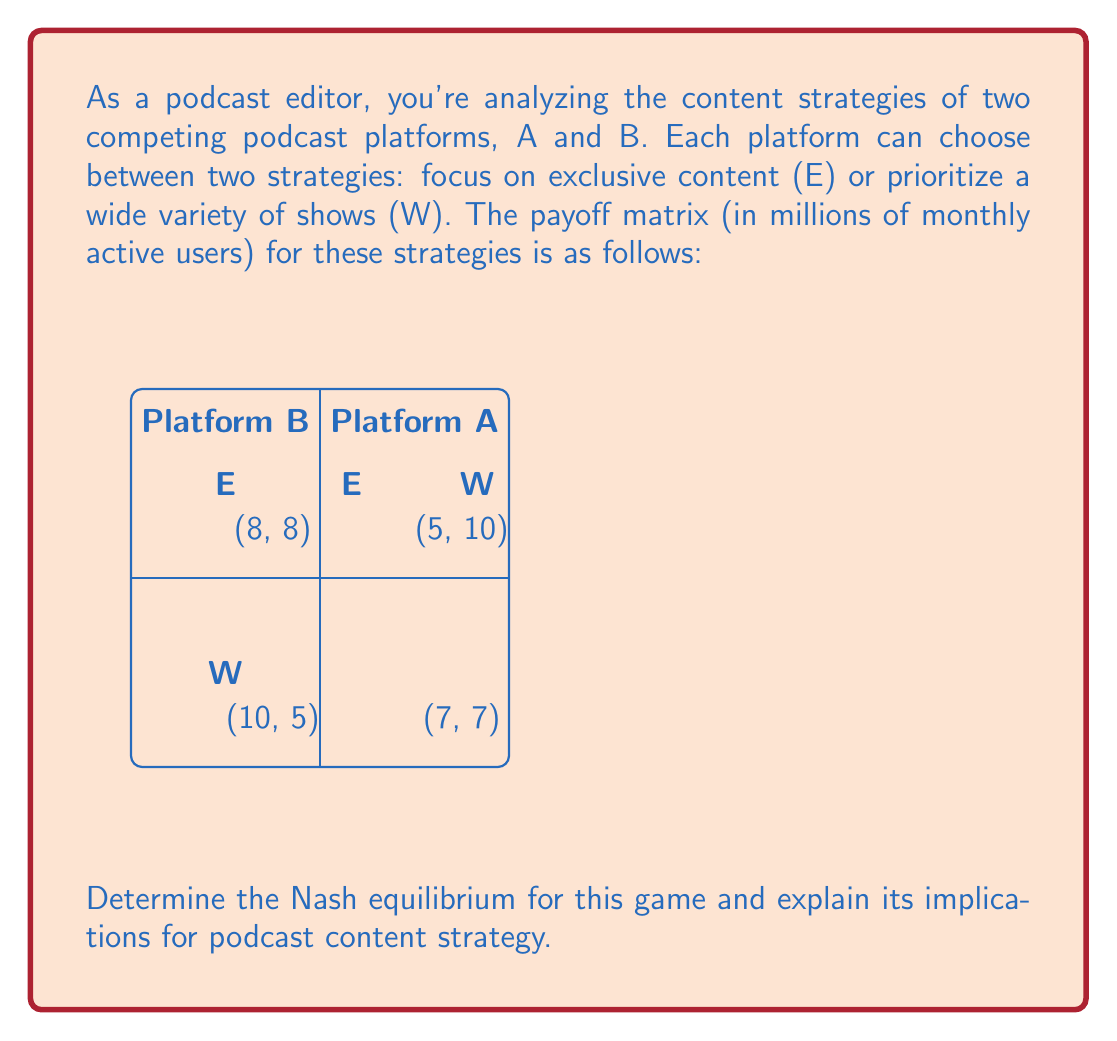Teach me how to tackle this problem. To find the Nash equilibrium, we need to analyze each platform's best response to the other's strategy:

1. For Platform A:
   - If B chooses E: A's best response is W (10 > 8)
   - If B chooses W: A's best response is E (5 > 7)

2. For Platform B:
   - If A chooses E: B's best response is W (10 > 8)
   - If A chooses W: B's best response is E (5 > 7)

3. Identify Nash equilibrium:
   A Nash equilibrium occurs when neither platform can unilaterally improve its payoff by changing its strategy.

   In this case, we have two Nash equilibria:
   a) (E, W): A chooses E, B chooses W
   b) (W, E): A chooses W, B chooses E

4. Verify equilibria:
   - For (E, W): 
     A gets 5 (can't improve by switching to W, which would give 7)
     B gets 10 (can't improve by switching to E, which would give 8)
   - For (W, E):
     A gets 10 (can't improve by switching to E, which would give 8)
     B gets 5 (can't improve by switching to W, which would give 7)

5. Implications for podcast content strategy:
   The Nash equilibria suggest that in a competitive market, it's beneficial for platforms to differentiate their strategies. One platform focuses on exclusive content, attracting loyal listeners, while the other offers a wide variety of shows, catering to diverse preferences. This differentiation allows both platforms to maintain a significant user base without direct head-to-head competition.
Answer: Two Nash equilibria: (E, W) and (W, E). Platforms benefit from differentiated content strategies. 